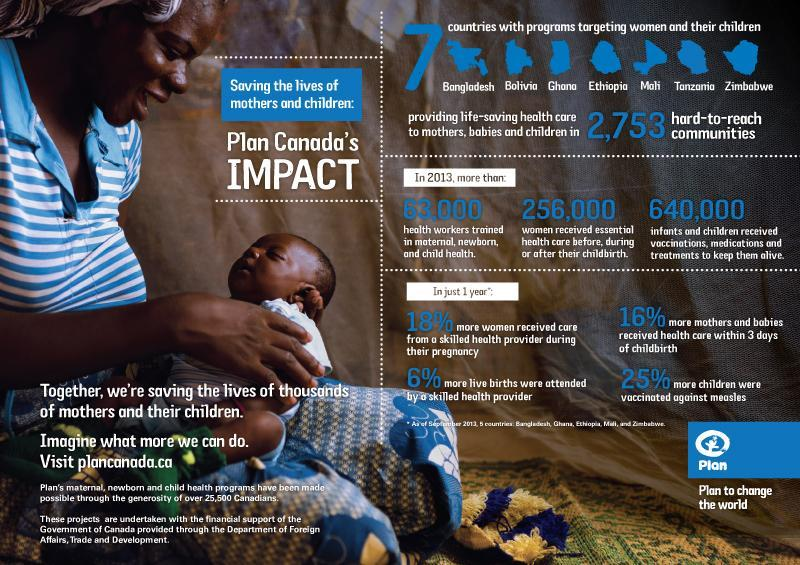Which country is listed in the infographic, India, USA or Tanzania?
Answer the question with a short phrase. Tanzania What is the increase in percentage in a year, for children who got measles vaccination? 25% What is the number of infants and children got vaccinations, medications and treatments to keep them alive in 2013? 640,000 What is the number of women who got essential health care before, during or after their childbirth in 2013? 256,000 